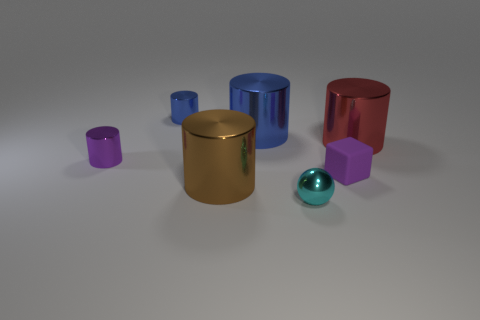Subtract 1 cylinders. How many cylinders are left? 4 Subtract all small blue metallic cylinders. How many cylinders are left? 4 Subtract all brown cylinders. How many cylinders are left? 4 Subtract all yellow cylinders. Subtract all blue balls. How many cylinders are left? 5 Add 3 green cylinders. How many objects exist? 10 Subtract all blocks. How many objects are left? 6 Add 7 big brown matte blocks. How many big brown matte blocks exist? 7 Subtract 0 red spheres. How many objects are left? 7 Subtract all small blue things. Subtract all small purple metallic things. How many objects are left? 5 Add 7 large shiny cylinders. How many large shiny cylinders are left? 10 